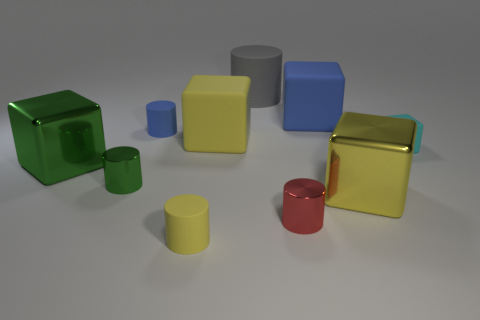Subtract 2 blocks. How many blocks are left? 3 Subtract all yellow rubber blocks. How many blocks are left? 4 Subtract all blue blocks. How many blocks are left? 4 Subtract all brown cylinders. Subtract all green blocks. How many cylinders are left? 5 Add 5 large green metal objects. How many large green metal objects exist? 6 Subtract 1 red cylinders. How many objects are left? 9 Subtract all small gray objects. Subtract all green metallic cylinders. How many objects are left? 9 Add 1 small cyan matte cubes. How many small cyan matte cubes are left? 2 